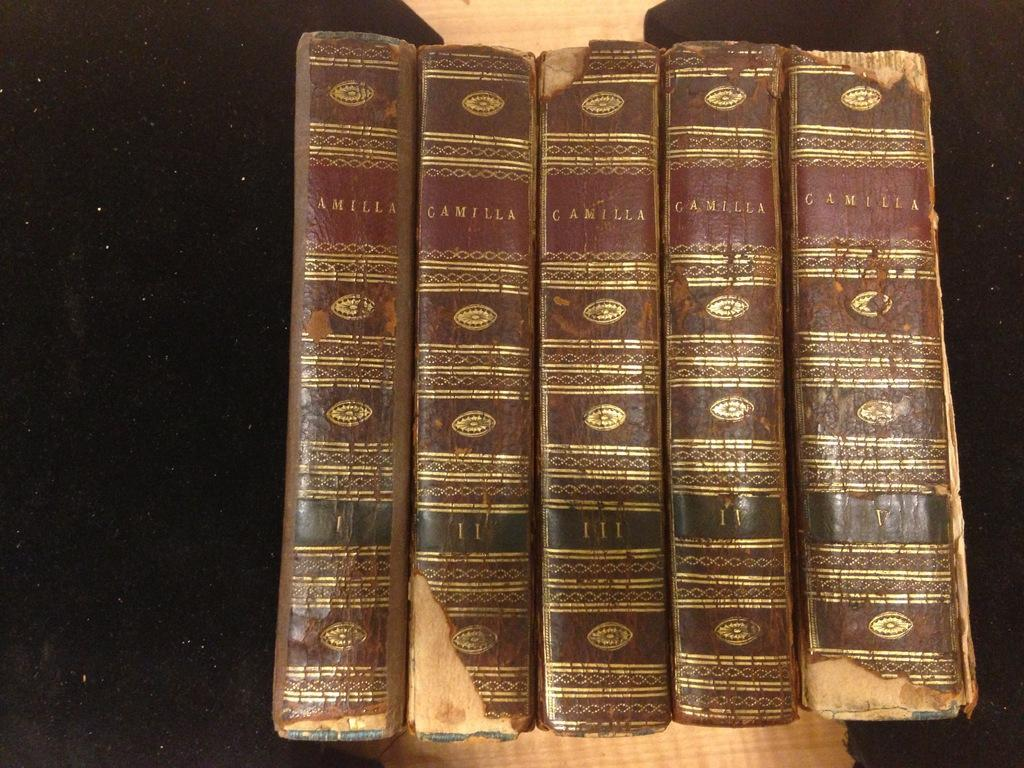<image>
Offer a succinct explanation of the picture presented. Some old books with the title Camilla on it 